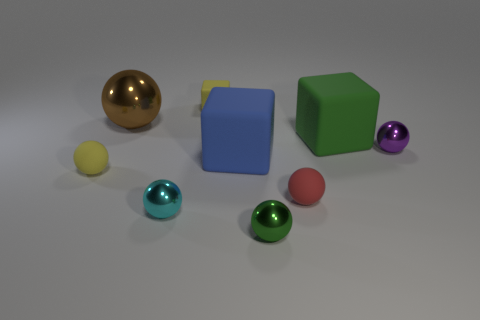There is a small matte thing that is behind the tiny purple metal ball; does it have the same shape as the big blue thing to the left of the small purple sphere?
Your answer should be compact. Yes. What is the size of the matte object that is both in front of the blue rubber block and right of the green metallic object?
Your answer should be compact. Small. How many other things are there of the same color as the small cube?
Your answer should be very brief. 1. Is the cube that is in front of the green rubber object made of the same material as the yellow sphere?
Offer a terse response. Yes. Are there fewer big brown metal things in front of the blue cube than small matte balls left of the tiny cyan thing?
Ensure brevity in your answer.  Yes. There is a ball that is the same color as the tiny rubber block; what is it made of?
Ensure brevity in your answer.  Rubber. What number of green objects are behind the yellow object that is to the left of the small yellow rubber thing that is behind the big blue rubber thing?
Your answer should be compact. 1. There is a large brown thing; how many large green matte cubes are left of it?
Provide a succinct answer. 0. What number of big cubes have the same material as the small cyan sphere?
Make the answer very short. 0. There is another big sphere that is made of the same material as the purple ball; what is its color?
Your response must be concise. Brown. 